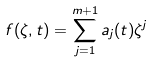Convert formula to latex. <formula><loc_0><loc_0><loc_500><loc_500>f ( \zeta , t ) = \sum _ { j = 1 } ^ { m + 1 } a _ { j } ( t ) \zeta ^ { j }</formula> 